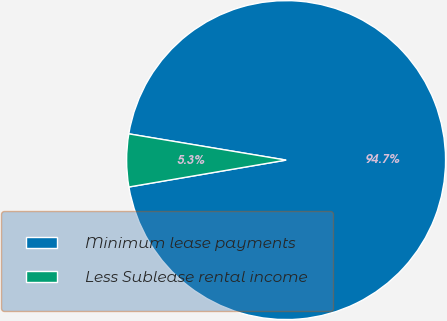Convert chart. <chart><loc_0><loc_0><loc_500><loc_500><pie_chart><fcel>Minimum lease payments<fcel>Less Sublease rental income<nl><fcel>94.67%<fcel>5.33%<nl></chart> 